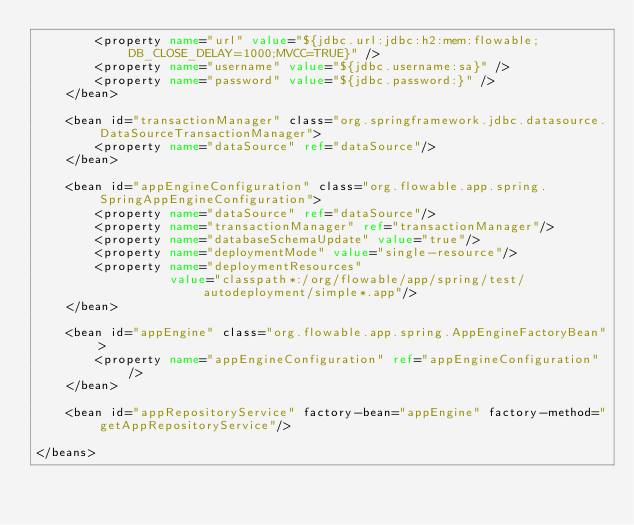Convert code to text. <code><loc_0><loc_0><loc_500><loc_500><_XML_>        <property name="url" value="${jdbc.url:jdbc:h2:mem:flowable;DB_CLOSE_DELAY=1000;MVCC=TRUE}" />
        <property name="username" value="${jdbc.username:sa}" />
        <property name="password" value="${jdbc.password:}" />
    </bean>

    <bean id="transactionManager" class="org.springframework.jdbc.datasource.DataSourceTransactionManager">
        <property name="dataSource" ref="dataSource"/>
    </bean>

    <bean id="appEngineConfiguration" class="org.flowable.app.spring.SpringAppEngineConfiguration">
        <property name="dataSource" ref="dataSource"/>
        <property name="transactionManager" ref="transactionManager"/>
        <property name="databaseSchemaUpdate" value="true"/>
        <property name="deploymentMode" value="single-resource"/>
        <property name="deploymentResources"
                  value="classpath*:/org/flowable/app/spring/test/autodeployment/simple*.app"/>
    </bean>

    <bean id="appEngine" class="org.flowable.app.spring.AppEngineFactoryBean">
        <property name="appEngineConfiguration" ref="appEngineConfiguration"/>
    </bean>

    <bean id="appRepositoryService" factory-bean="appEngine" factory-method="getAppRepositoryService"/>

</beans></code> 